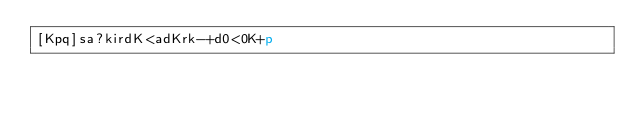<code> <loc_0><loc_0><loc_500><loc_500><_dc_>[Kpq]sa?kirdK<adKrk-+d0<0K+p</code> 